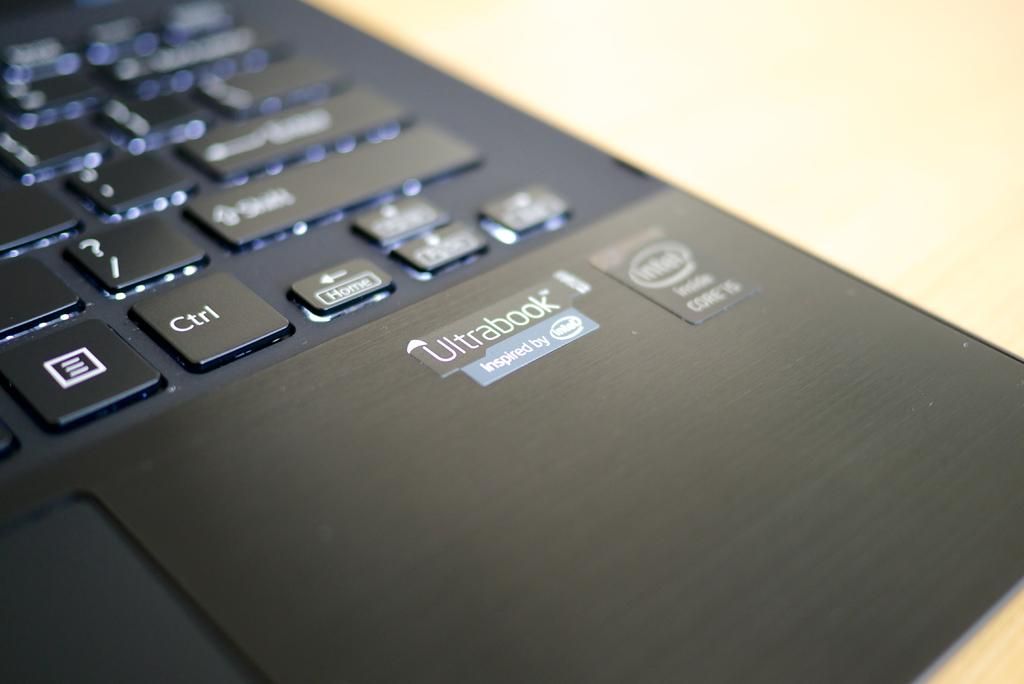Provide a one-sentence caption for the provided image. Bottom right corner of a black ultrabook is shown with its logo. 